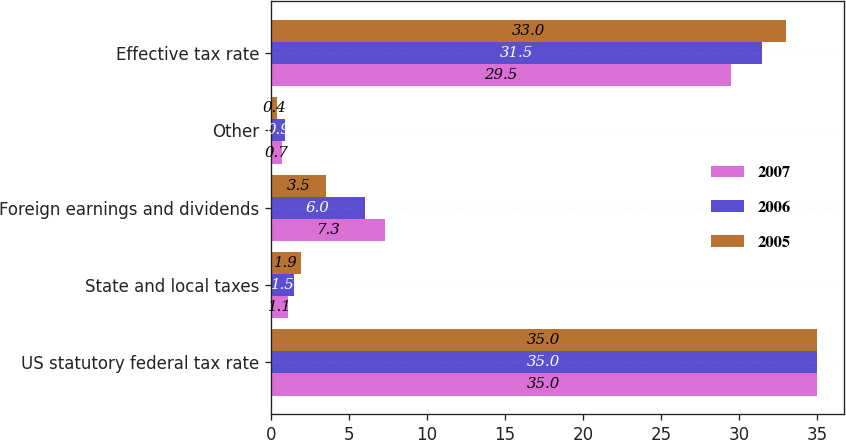<chart> <loc_0><loc_0><loc_500><loc_500><stacked_bar_chart><ecel><fcel>US statutory federal tax rate<fcel>State and local taxes<fcel>Foreign earnings and dividends<fcel>Other<fcel>Effective tax rate<nl><fcel>2007<fcel>35<fcel>1.1<fcel>7.3<fcel>0.7<fcel>29.5<nl><fcel>2006<fcel>35<fcel>1.5<fcel>6<fcel>0.9<fcel>31.5<nl><fcel>2005<fcel>35<fcel>1.9<fcel>3.5<fcel>0.4<fcel>33<nl></chart> 